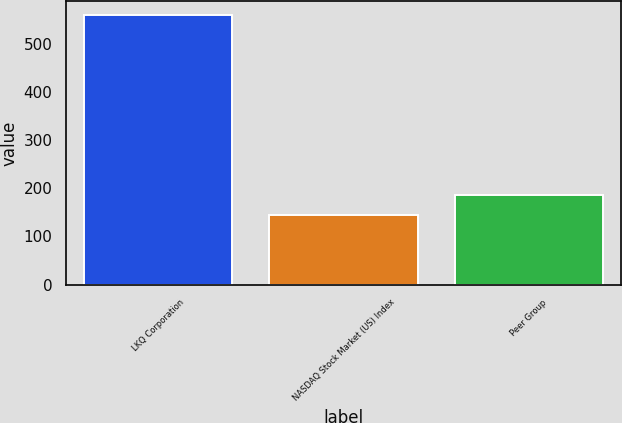Convert chart to OTSL. <chart><loc_0><loc_0><loc_500><loc_500><bar_chart><fcel>LKQ Corporation<fcel>NASDAQ Stock Market (US) Index<fcel>Peer Group<nl><fcel>561<fcel>144<fcel>186<nl></chart> 